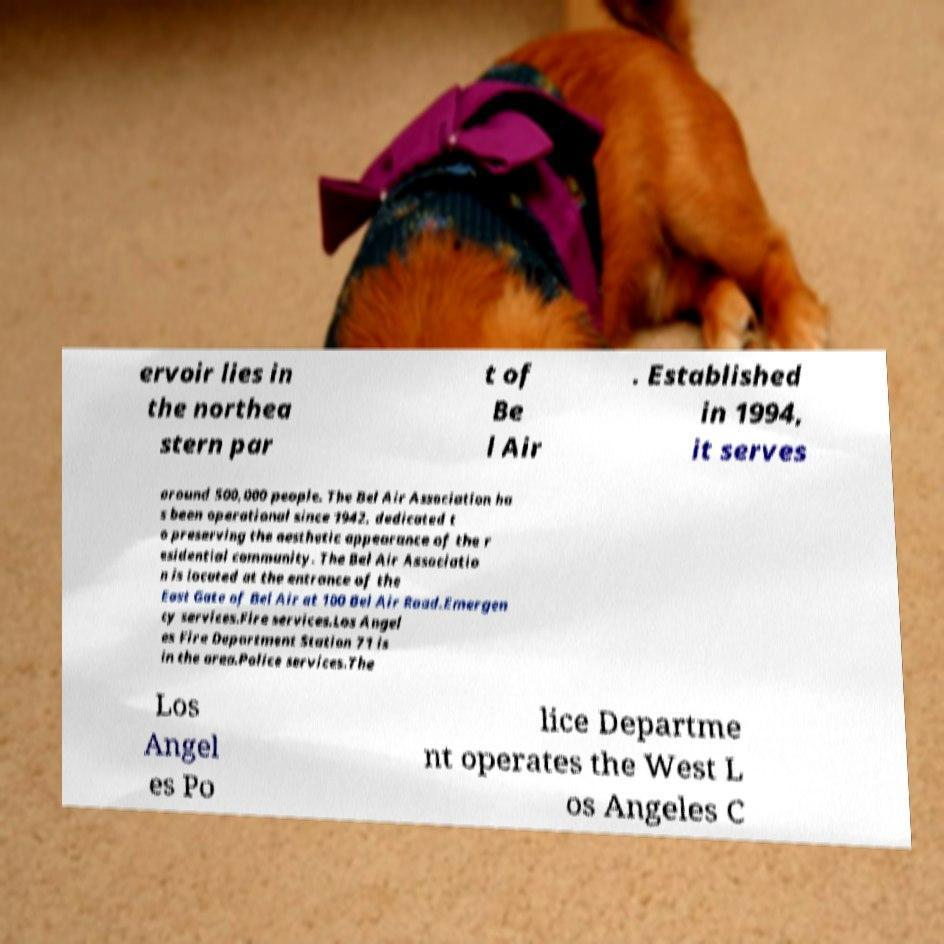For documentation purposes, I need the text within this image transcribed. Could you provide that? ervoir lies in the northea stern par t of Be l Air . Established in 1994, it serves around 500,000 people. The Bel Air Association ha s been operational since 1942, dedicated t o preserving the aesthetic appearance of the r esidential community. The Bel Air Associatio n is located at the entrance of the East Gate of Bel Air at 100 Bel Air Road.Emergen cy services.Fire services.Los Angel es Fire Department Station 71 is in the area.Police services.The Los Angel es Po lice Departme nt operates the West L os Angeles C 